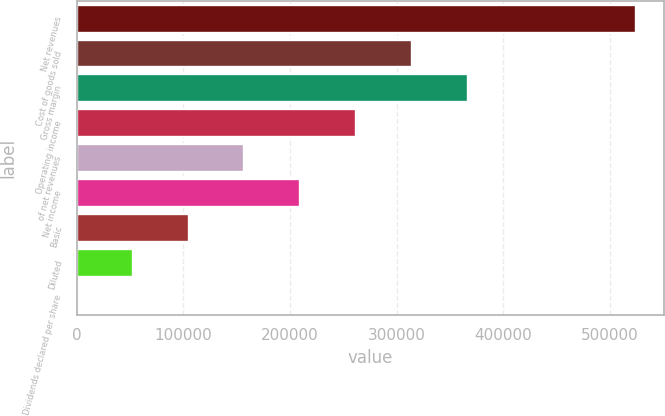Convert chart. <chart><loc_0><loc_0><loc_500><loc_500><bar_chart><fcel>Net revenues<fcel>Cost of goods sold<fcel>Gross margin<fcel>Operating income<fcel>of net revenues<fcel>Net income<fcel>Basic<fcel>Diluted<fcel>Dividends declared per share<nl><fcel>524081<fcel>314449<fcel>366857<fcel>262041<fcel>157224<fcel>209633<fcel>104816<fcel>52408.3<fcel>0.19<nl></chart> 